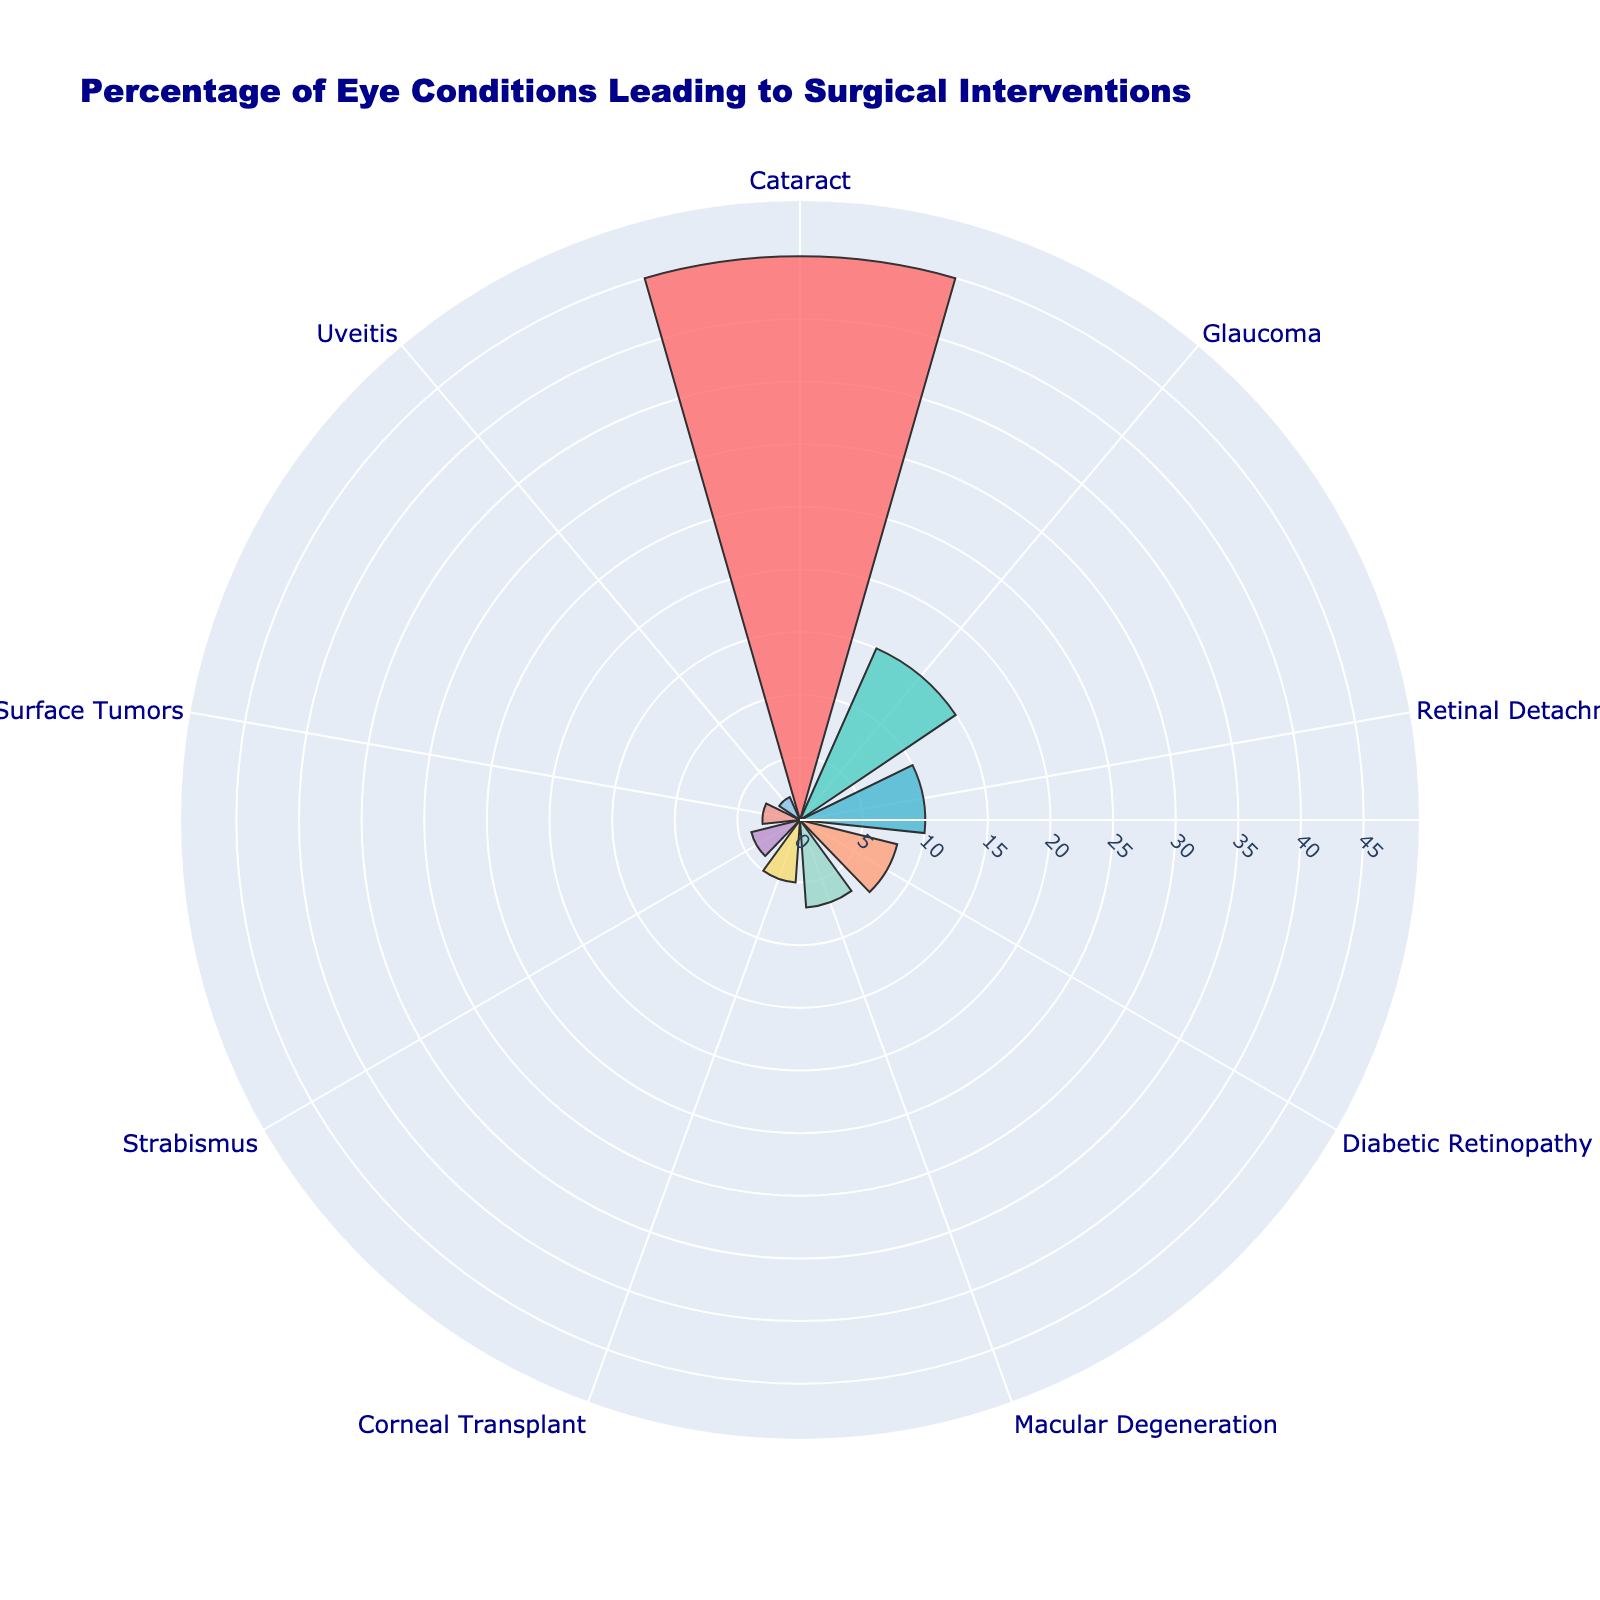Which condition has the highest percentage of surgical interventions? The title of the chart suggests that the data represents percentages of various eye conditions leading to surgical interventions. Observing the chart, the largest segment corresponds to the condition "Cataract", which has the highest percentage.
Answer: Cataract How many eye conditions are presented in the chart? By counting the distinct segments representing different conditions, we can determine the number of eye conditions displayed in the chart. The chart clearly shows 9 segments.
Answer: 9 What is the combined percentage of Glaucoma and Retinal Detachment surgeries? To find the combined percentage, sum the percentages of Glaucoma and Retinal Detachment. From the chart, Glaucoma is 15% and Retinal Detachment is 10%. Adding these gives 15% + 10% = 25%.
Answer: 25% Which condition has a lower percentage of surgical interventions, Strabismus or Uveitis? Comparing the sizes of the segments for Strabismus and Uveitis, we see that Strabismus has a segment representing 4%, while Uveitis has a segment representing 2%. Therefore, Uveitis has a lower percentage.
Answer: Uveitis What is the difference in percentage between Macular Degeneration and Diabetic Retinopathy surgeries? Subtract the percentage of Macular Degeneration from Diabetic Retinopathy. From the chart, Diabetic Retinopathy is 8% and Macular Degeneration is 7%. The difference is 8% - 7% = 1%.
Answer: 1% How does the percentage of Corneal Transplant surgeries compare to Ocular Surface Tumors surgeries? Comparing the segments, Corneal Transplant has a percentage of 5%, and Ocular Surface Tumors has 3%. Therefore, Corneal Transplant has a higher percentage than Ocular Surface Tumors.
Answer: Corneal Transplant has a higher percentage What percentage of the surgical interventions is accounted for by Cataract, Glaucoma, and Retinal Detachment combined? Combine the percentages of Cataract, Glaucoma, and Retinal Detachment by summing them. From the chart, Cataract is 45%, Glaucoma is 15%, and Retinal Detachment is 10%. Adding these: 45% + 15% + 10% = 70%.
Answer: 70% Which conditions have a percentage of surgical interventions less than 5%? Observing the segments with percentages less than 5%, Strabismus (4%), Ocular Surface Tumors (3%), and Uveitis (2%) fall into this category.
Answer: Strabismus, Ocular Surface Tumors, Uveitis What is the average percentage of all the conditions listed? To calculate the average, sum all the percentages and then divide by the number of conditions. The sum is 45% + 15% + 10% + 8% + 7% + 5% + 4% + 3% + 2% = 99%. Dividing by 9 conditions, the average is 99% / 9 = 11%.
Answer: 11% 